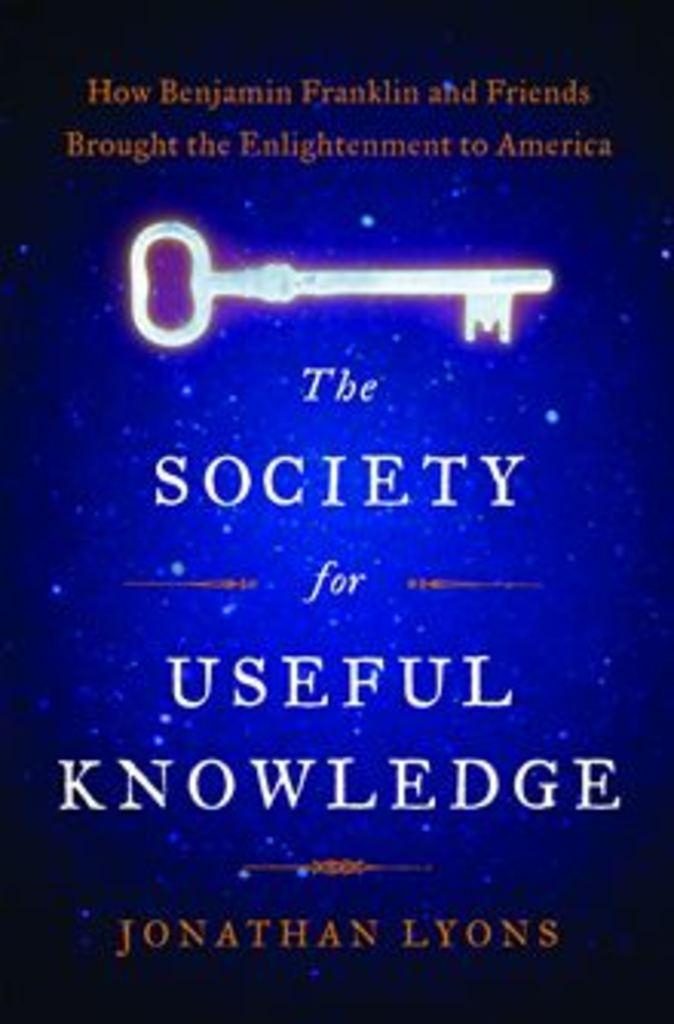<image>
Present a compact description of the photo's key features. A book entitled The Society for Useful Knowledge features an image of a key on its cover. 